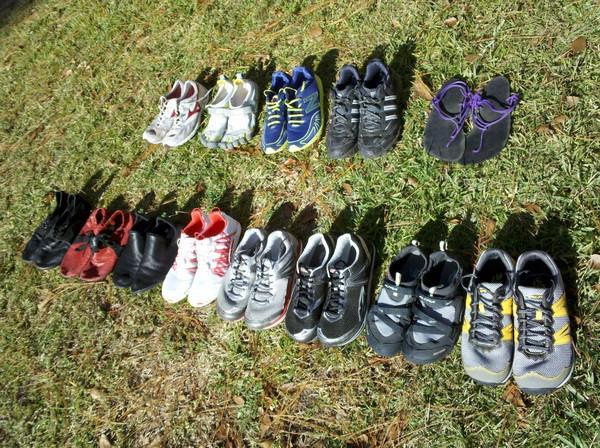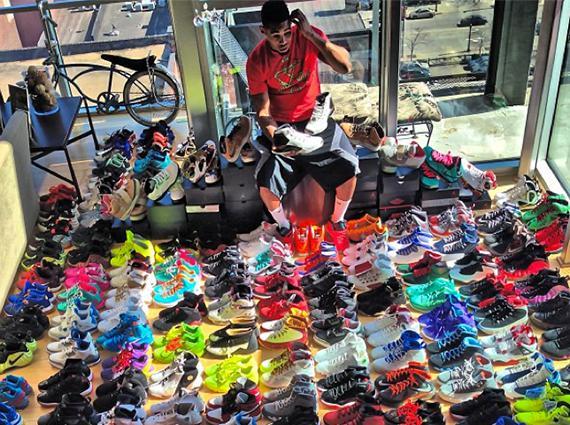The first image is the image on the left, the second image is the image on the right. For the images shown, is this caption "there are at most2 pair of shoes per image pair" true? Answer yes or no. No. 